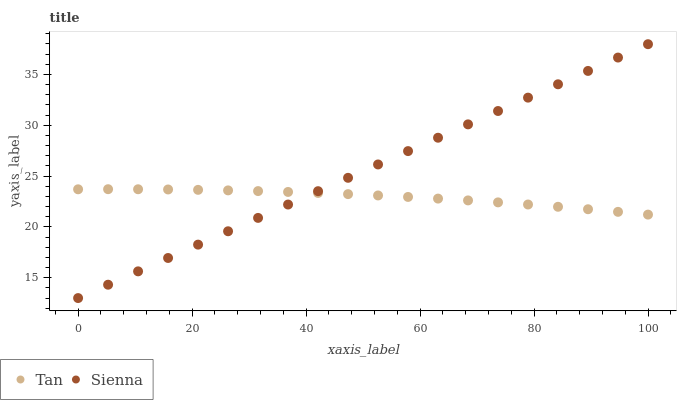Does Tan have the minimum area under the curve?
Answer yes or no. Yes. Does Sienna have the maximum area under the curve?
Answer yes or no. Yes. Does Tan have the maximum area under the curve?
Answer yes or no. No. Is Sienna the smoothest?
Answer yes or no. Yes. Is Tan the roughest?
Answer yes or no. Yes. Is Tan the smoothest?
Answer yes or no. No. Does Sienna have the lowest value?
Answer yes or no. Yes. Does Tan have the lowest value?
Answer yes or no. No. Does Sienna have the highest value?
Answer yes or no. Yes. Does Tan have the highest value?
Answer yes or no. No. Does Tan intersect Sienna?
Answer yes or no. Yes. Is Tan less than Sienna?
Answer yes or no. No. Is Tan greater than Sienna?
Answer yes or no. No. 